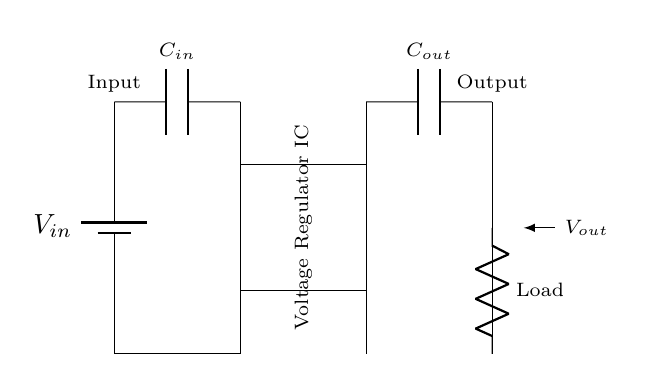What is the input component in this circuit? The input component is the battery, labeled V in, providing the input voltage to the circuit.
Answer: battery What component regulates the voltage in this circuit? The component that regulates the voltage is the voltage regulator IC, which ensures the output voltage remains stable.
Answer: Voltage Regulator IC What is the purpose of the output capacitor in this circuit? The output capacitor smooths the output voltage, reducing any voltage fluctuations and providing a stable output for connected devices.
Answer: Smooth voltage How many capacitors are present in the circuit? There are two capacitors in the circuit, one at the input (C in) and one at the output (C out), which help in filtering and stabilizing the voltage.
Answer: Two What is the role of the load in this circuit? The load represents the devices powered by the circuit, where the regulated output voltage is delivered for operation.
Answer: Powering devices What is the output voltage denoted in this circuit? The output voltage is marked as V out, representing the voltage supplied to the load after regulation.
Answer: V out Why are ground connections important in this circuit? Ground connections are crucial as they provide a reference point for all voltages in the circuit and help in stabilizing the circuit operation.
Answer: Stabilizing reference 